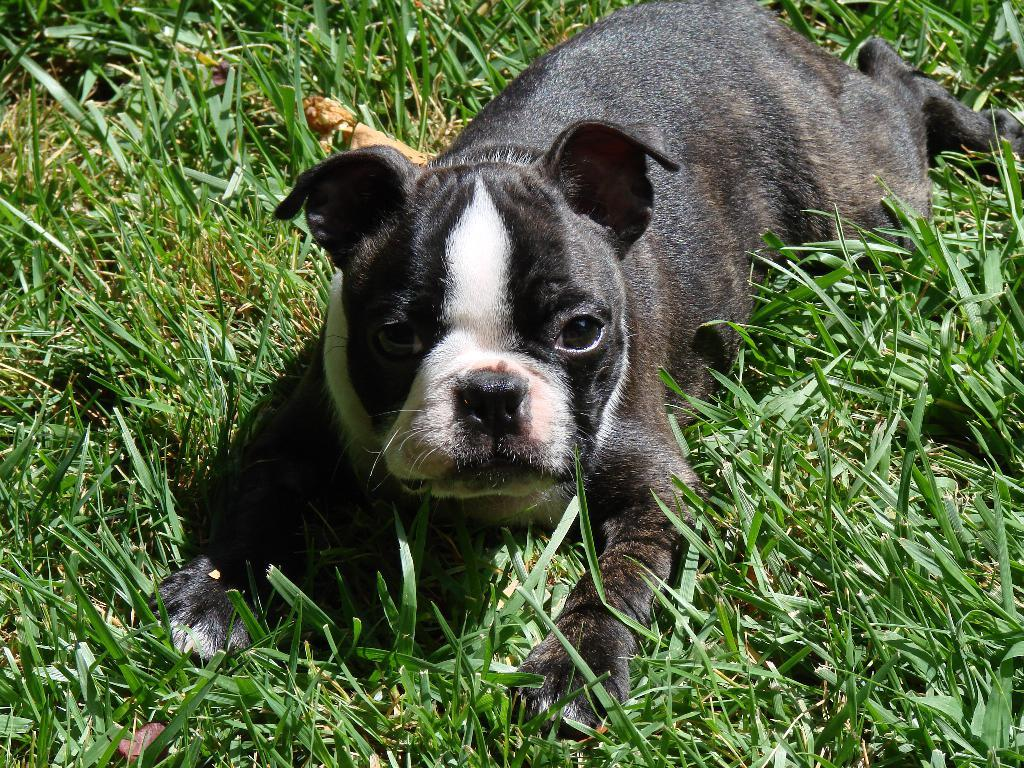What type of animal is in the image? There is a dog in the image. Can you describe the dog's coloring? The dog has black, brown, and white coloring. What is the ground made of in the image? There is grass on the ground in the image. What type of friction can be observed between the dog and the jar in the image? There is no jar present in the image, so no friction can be observed between the dog and a jar. 